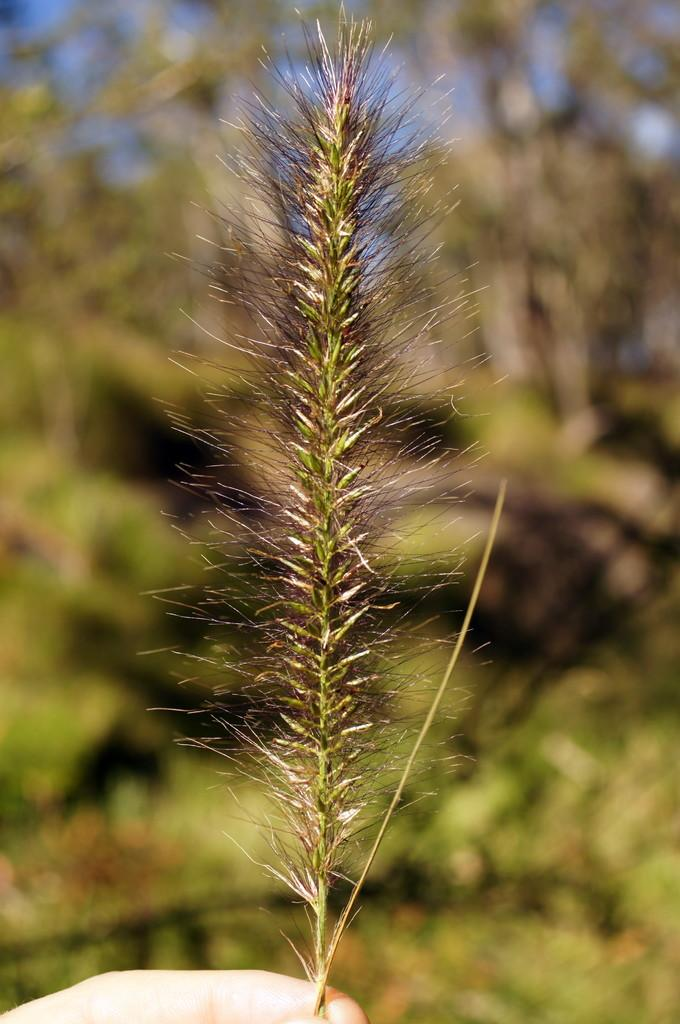What is being held in the human hand in the image? There is a leaf in a human hand in the image. What can be seen in the background of the image? There are trees in the background of the image. What type of attraction is being approved by the person in the image? There is no indication of an attraction or approval in the image; it only shows a leaf in a human hand and trees in the background. 